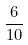Convert formula to latex. <formula><loc_0><loc_0><loc_500><loc_500>\frac { 6 } { 1 0 }</formula> 